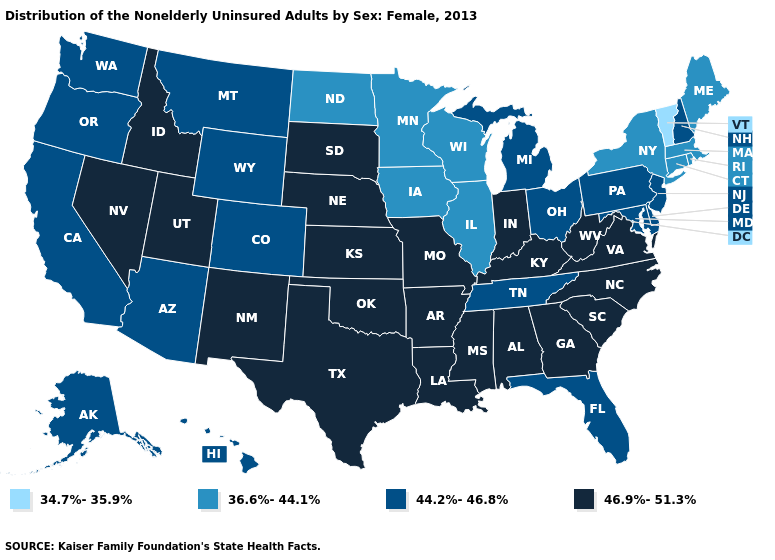Does Michigan have a higher value than West Virginia?
Answer briefly. No. Does the map have missing data?
Be succinct. No. What is the value of Alabama?
Quick response, please. 46.9%-51.3%. Among the states that border Nevada , which have the lowest value?
Short answer required. Arizona, California, Oregon. Name the states that have a value in the range 34.7%-35.9%?
Quick response, please. Vermont. Name the states that have a value in the range 44.2%-46.8%?
Write a very short answer. Alaska, Arizona, California, Colorado, Delaware, Florida, Hawaii, Maryland, Michigan, Montana, New Hampshire, New Jersey, Ohio, Oregon, Pennsylvania, Tennessee, Washington, Wyoming. Among the states that border Kansas , does Colorado have the lowest value?
Keep it brief. Yes. Name the states that have a value in the range 44.2%-46.8%?
Concise answer only. Alaska, Arizona, California, Colorado, Delaware, Florida, Hawaii, Maryland, Michigan, Montana, New Hampshire, New Jersey, Ohio, Oregon, Pennsylvania, Tennessee, Washington, Wyoming. What is the highest value in the MidWest ?
Give a very brief answer. 46.9%-51.3%. Is the legend a continuous bar?
Short answer required. No. What is the lowest value in states that border Maine?
Give a very brief answer. 44.2%-46.8%. What is the lowest value in the West?
Keep it brief. 44.2%-46.8%. What is the value of Louisiana?
Give a very brief answer. 46.9%-51.3%. 